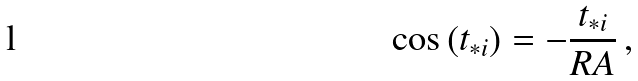Convert formula to latex. <formula><loc_0><loc_0><loc_500><loc_500>\cos \left ( t _ { * i } \right ) = - \frac { t _ { * i } } { R A } \, ,</formula> 